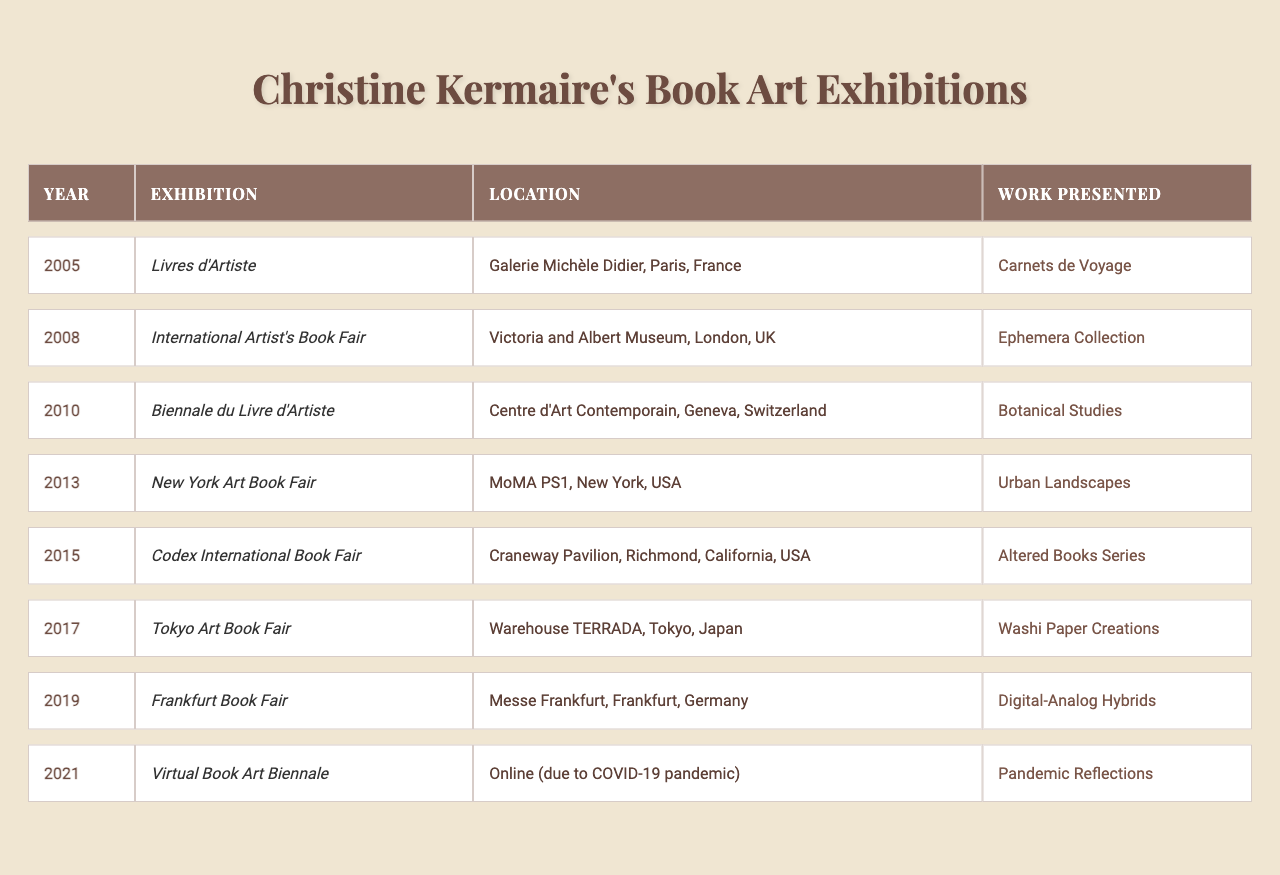What year did Christine Kermaire exhibit at the International Artist's Book Fair? Referring to the table, the exhibition "International Artist's Book Fair" took place in the year 2008.
Answer: 2008 Which exhibition featured the work "Carnets de Voyage"? According to the table, the work "Carnets de Voyage" was presented at the "Livres d'Artiste" exhibition in 2005.
Answer: Livres d'Artiste How many exhibitions were held in the year 2010 or later? Reviewing the table, there are four exhibitions listed in 2010 or later: "Biennale du Livre d'Artiste" (2010), "New York Art Book Fair" (2013), "Codex International Book Fair" (2015), "Tokyo Art Book Fair" (2017), "Frankfurt Book Fair" (2019), and "Virtual Book Art Biennale" (2021), totaling six.
Answer: 6 Which location hosted the exhibition in 2015? The table shows that the 2015 exhibition, "Codex International Book Fair," took place at the Craneway Pavilion in Richmond, California, USA.
Answer: Craneway Pavilion, Richmond, California, USA Was "Digital-Analog Hybrids" exhibited in a year before 2020? Checking the table, "Digital-Analog Hybrids" was presented at the "Frankfurt Book Fair" in 2019, which is indeed before 2020.
Answer: Yes How many different locations have hosted Christine Kermaire's exhibitions based on the table? From the data in the table, the following locations are present: Paris, London, Geneva, New York, Richmond, Tokyo, Frankfurt, and Online for a total of seven different locations.
Answer: 7 What is the title of the work presented at the 2013 exhibition? Referring to the table, the work presented at the 2013 "New York Art Book Fair" was "Urban Landscapes."
Answer: Urban Landscapes In which exhibition was "Pandemic Reflections" showcased? The table indicates that "Pandemic Reflections" was showcased during the "Virtual Book Art Biennale" in 2021.
Answer: Virtual Book Art Biennale What was the difference in years between the earliest and latest exhibitions listed? Observing the years from the table, the earliest exhibition is in 2005 and the latest is in 2021. The difference is 2021 - 2005 = 16 years.
Answer: 16 years Which exhibition took place online due to the COVID-19 pandemic? According to the table, the exhibition "Virtual Book Art Biennale" held in 2021 took place online due to the COVID-19 pandemic.
Answer: Virtual Book Art Biennale 